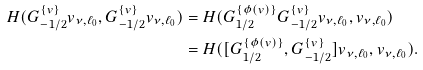Convert formula to latex. <formula><loc_0><loc_0><loc_500><loc_500>H ( G ^ { \{ v \} } _ { - 1 / 2 } v _ { \nu , \ell _ { 0 } } , G ^ { \{ v \} } _ { - 1 / 2 } v _ { \nu , \ell _ { 0 } } ) & = H ( G ^ { \{ \phi ( v ) \} } _ { 1 / 2 } G ^ { \{ v \} } _ { - 1 / 2 } v _ { \nu , \ell _ { 0 } } , v _ { \nu , \ell _ { 0 } } ) \\ & = H ( [ G ^ { \{ \phi ( v ) \} } _ { 1 / 2 } , G ^ { \{ v \} } _ { - 1 / 2 } ] v _ { \nu , \ell _ { 0 } } , v _ { \nu , \ell _ { 0 } } ) .</formula> 